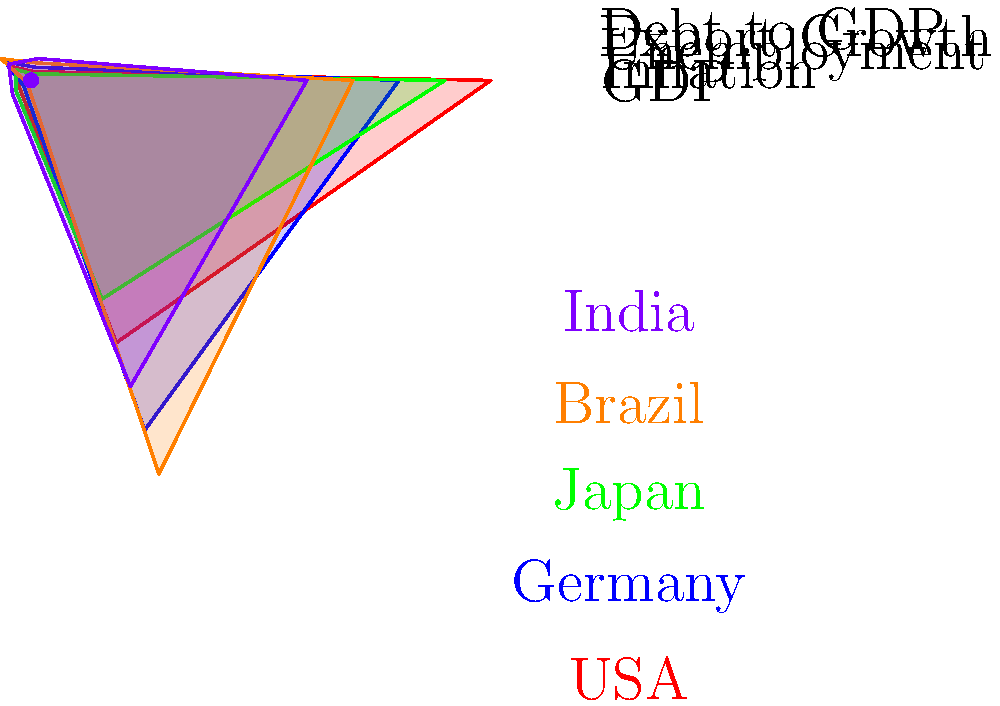Based on the star plot in polar coordinates comparing economic indicators of different countries, which country appears to have the highest GDP and the lowest inflation rate? To answer this question, we need to analyze the star plot carefully:

1. First, identify the GDP axis, which is at the top of the star plot.
2. Look for the country with the longest spoke on the GDP axis. This represents the highest GDP.
3. The red line, representing the USA, extends the furthest on the GDP axis.
4. Next, locate the inflation axis, which is the second spoke moving clockwise.
5. Look for the country with the shortest spoke on the inflation axis, as this represents the lowest inflation rate.
6. The green line, representing Japan, has the shortest spoke on the inflation axis.

Therefore, by examining the star plot, we can conclude that:
- The USA (red) has the highest GDP
- Japan (green) has the lowest inflation rate

Combining these observations, we can determine that the USA has the highest GDP, but Japan has the lowest inflation rate.
Answer: No single country; USA has highest GDP, Japan has lowest inflation. 